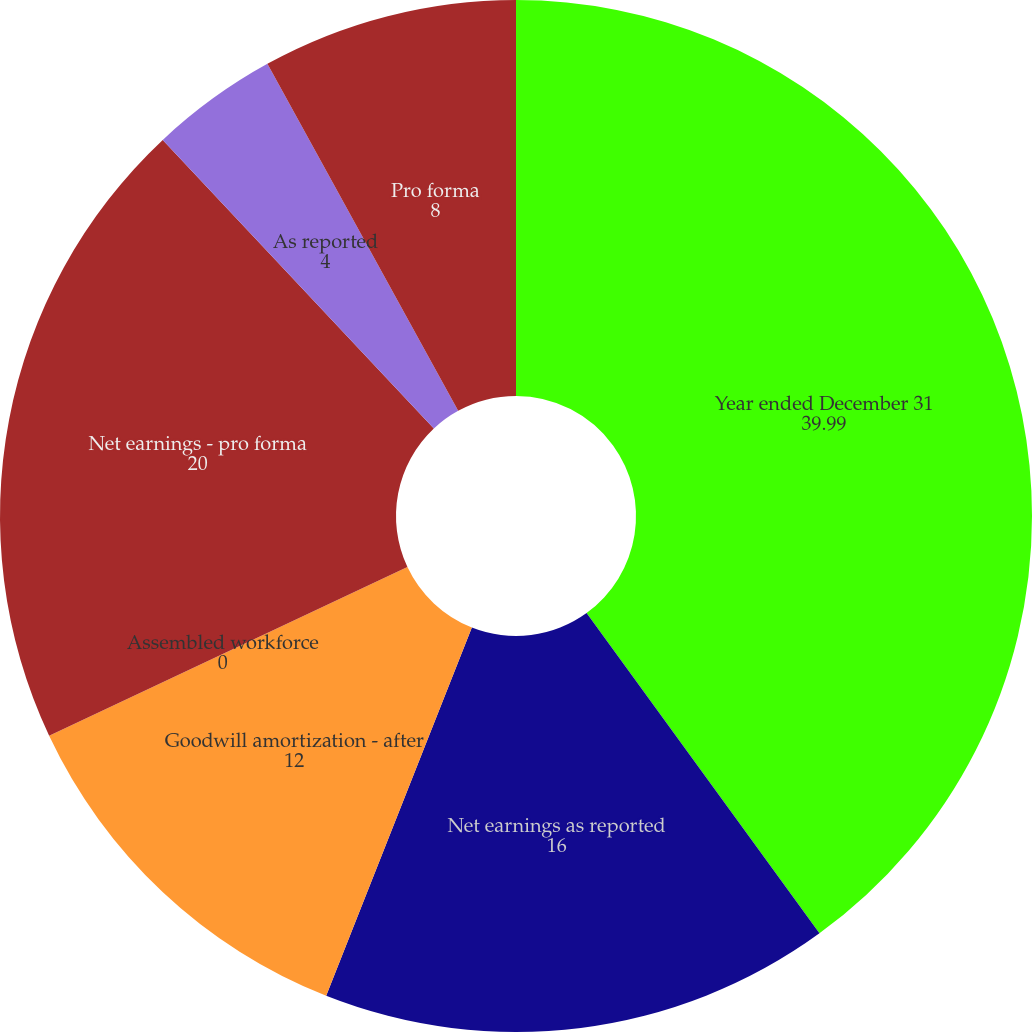<chart> <loc_0><loc_0><loc_500><loc_500><pie_chart><fcel>Year ended December 31<fcel>Net earnings as reported<fcel>Goodwill amortization - after<fcel>Assembled workforce<fcel>Net earnings - pro forma<fcel>As reported<fcel>Pro forma<nl><fcel>39.99%<fcel>16.0%<fcel>12.0%<fcel>0.0%<fcel>20.0%<fcel>4.0%<fcel>8.0%<nl></chart> 